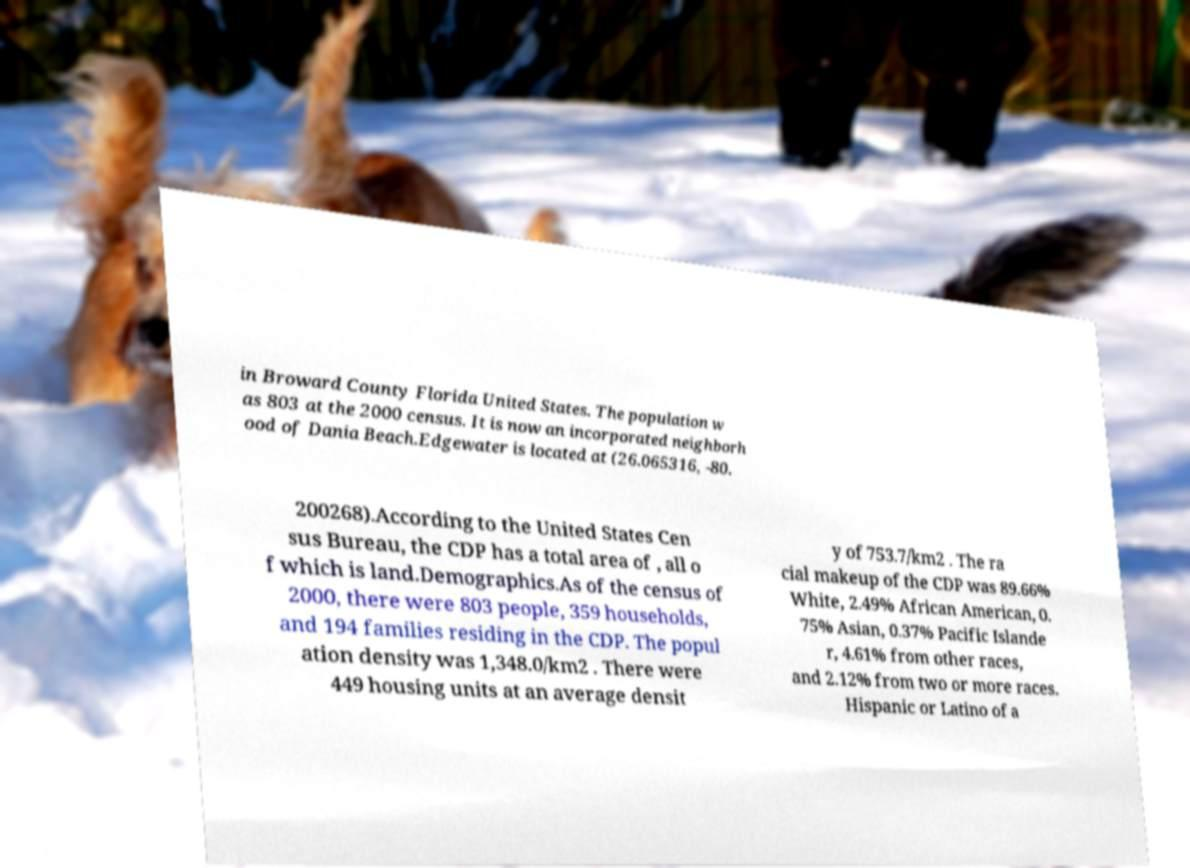There's text embedded in this image that I need extracted. Can you transcribe it verbatim? in Broward County Florida United States. The population w as 803 at the 2000 census. It is now an incorporated neighborh ood of Dania Beach.Edgewater is located at (26.065316, -80. 200268).According to the United States Cen sus Bureau, the CDP has a total area of , all o f which is land.Demographics.As of the census of 2000, there were 803 people, 359 households, and 194 families residing in the CDP. The popul ation density was 1,348.0/km2 . There were 449 housing units at an average densit y of 753.7/km2 . The ra cial makeup of the CDP was 89.66% White, 2.49% African American, 0. 75% Asian, 0.37% Pacific Islande r, 4.61% from other races, and 2.12% from two or more races. Hispanic or Latino of a 